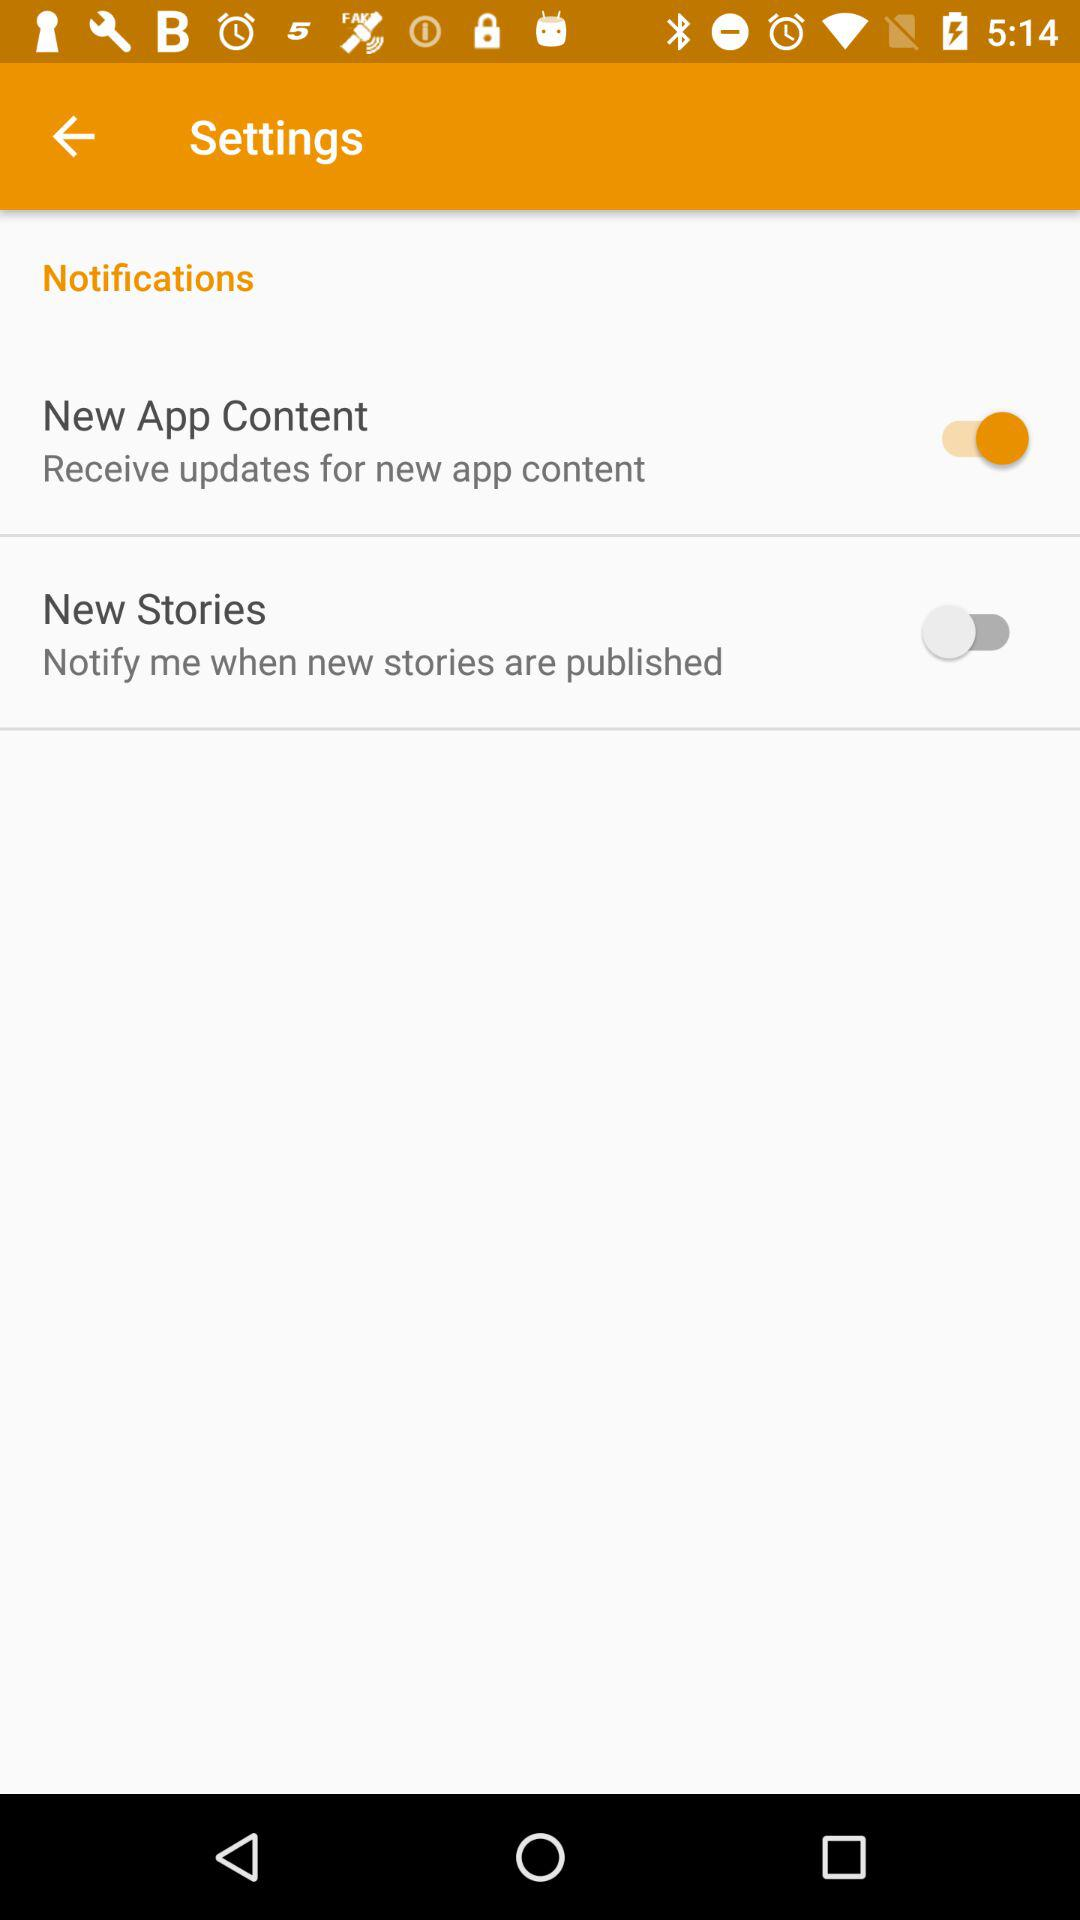What is the status of New Stories? The status is off. 